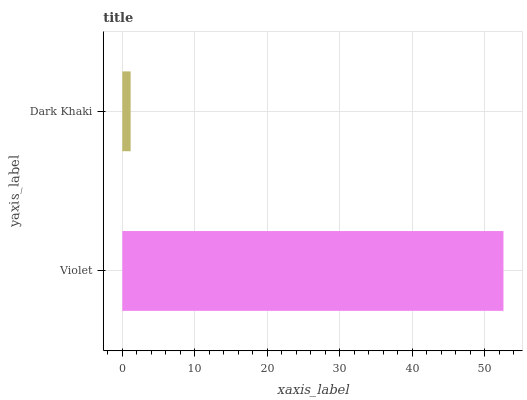Is Dark Khaki the minimum?
Answer yes or no. Yes. Is Violet the maximum?
Answer yes or no. Yes. Is Dark Khaki the maximum?
Answer yes or no. No. Is Violet greater than Dark Khaki?
Answer yes or no. Yes. Is Dark Khaki less than Violet?
Answer yes or no. Yes. Is Dark Khaki greater than Violet?
Answer yes or no. No. Is Violet less than Dark Khaki?
Answer yes or no. No. Is Violet the high median?
Answer yes or no. Yes. Is Dark Khaki the low median?
Answer yes or no. Yes. Is Dark Khaki the high median?
Answer yes or no. No. Is Violet the low median?
Answer yes or no. No. 